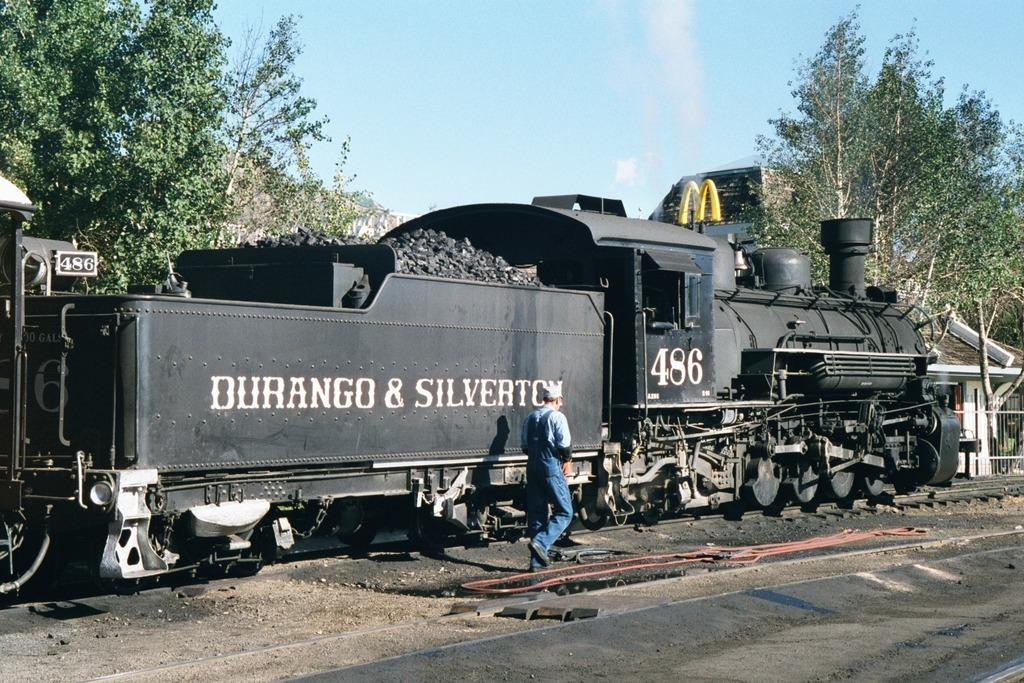What is the main subject of the image? The main subject of the image is a train. Where is the train located in the image? The train is on a rail track in the image. What can be seen near the train? Coal is visible in the image. What is the person in the image doing? There is a person walking in the image. What type of vegetation is present in the image? Trees are present in the image. What type of structure can be seen in the image? There is a building in the image. What type of sugar can be seen in the image? There is no sugar present in the image. 